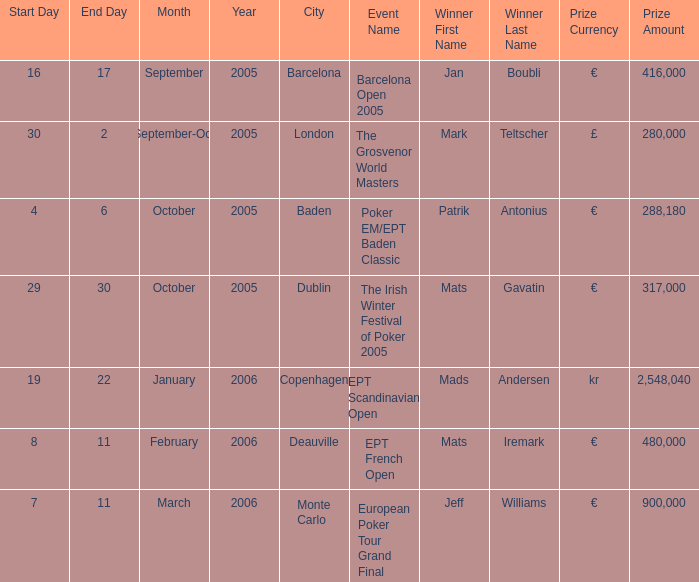What was the date of the occurrence in baden city? 4–6 October 2005. 